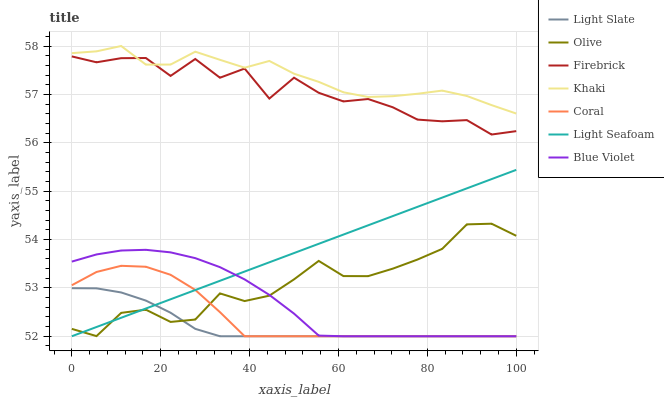Does Light Slate have the minimum area under the curve?
Answer yes or no. Yes. Does Khaki have the maximum area under the curve?
Answer yes or no. Yes. Does Firebrick have the minimum area under the curve?
Answer yes or no. No. Does Firebrick have the maximum area under the curve?
Answer yes or no. No. Is Light Seafoam the smoothest?
Answer yes or no. Yes. Is Firebrick the roughest?
Answer yes or no. Yes. Is Light Slate the smoothest?
Answer yes or no. No. Is Light Slate the roughest?
Answer yes or no. No. Does Light Slate have the lowest value?
Answer yes or no. Yes. Does Firebrick have the lowest value?
Answer yes or no. No. Does Khaki have the highest value?
Answer yes or no. Yes. Does Firebrick have the highest value?
Answer yes or no. No. Is Olive less than Firebrick?
Answer yes or no. Yes. Is Firebrick greater than Blue Violet?
Answer yes or no. Yes. Does Light Slate intersect Olive?
Answer yes or no. Yes. Is Light Slate less than Olive?
Answer yes or no. No. Is Light Slate greater than Olive?
Answer yes or no. No. Does Olive intersect Firebrick?
Answer yes or no. No. 